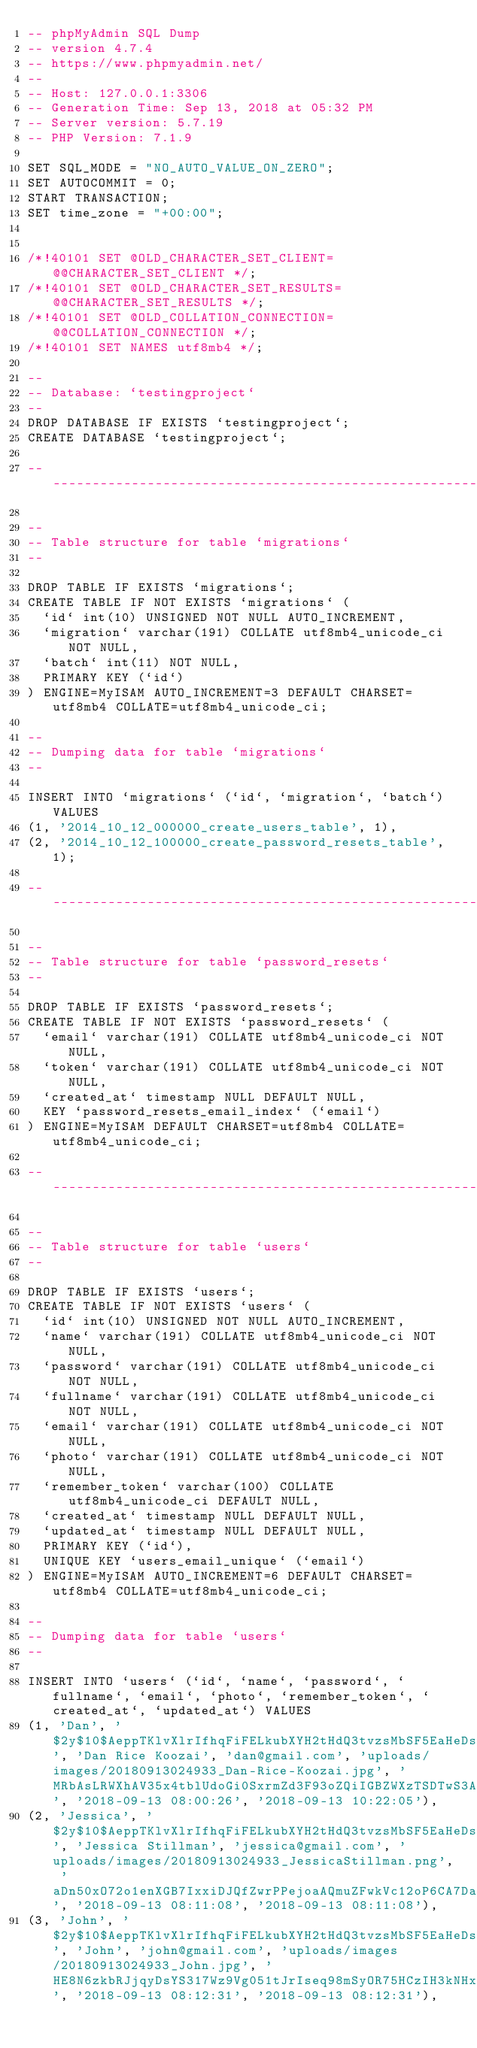<code> <loc_0><loc_0><loc_500><loc_500><_SQL_>-- phpMyAdmin SQL Dump
-- version 4.7.4
-- https://www.phpmyadmin.net/
--
-- Host: 127.0.0.1:3306
-- Generation Time: Sep 13, 2018 at 05:32 PM
-- Server version: 5.7.19
-- PHP Version: 7.1.9

SET SQL_MODE = "NO_AUTO_VALUE_ON_ZERO";
SET AUTOCOMMIT = 0;
START TRANSACTION;
SET time_zone = "+00:00";


/*!40101 SET @OLD_CHARACTER_SET_CLIENT=@@CHARACTER_SET_CLIENT */;
/*!40101 SET @OLD_CHARACTER_SET_RESULTS=@@CHARACTER_SET_RESULTS */;
/*!40101 SET @OLD_COLLATION_CONNECTION=@@COLLATION_CONNECTION */;
/*!40101 SET NAMES utf8mb4 */;

--
-- Database: `testingproject`
--
DROP DATABASE IF EXISTS `testingproject`;
CREATE DATABASE `testingproject`;

-- --------------------------------------------------------

--
-- Table structure for table `migrations`
--

DROP TABLE IF EXISTS `migrations`;
CREATE TABLE IF NOT EXISTS `migrations` (
  `id` int(10) UNSIGNED NOT NULL AUTO_INCREMENT,
  `migration` varchar(191) COLLATE utf8mb4_unicode_ci NOT NULL,
  `batch` int(11) NOT NULL,
  PRIMARY KEY (`id`)
) ENGINE=MyISAM AUTO_INCREMENT=3 DEFAULT CHARSET=utf8mb4 COLLATE=utf8mb4_unicode_ci;

--
-- Dumping data for table `migrations`
--

INSERT INTO `migrations` (`id`, `migration`, `batch`) VALUES
(1, '2014_10_12_000000_create_users_table', 1),
(2, '2014_10_12_100000_create_password_resets_table', 1);

-- --------------------------------------------------------

--
-- Table structure for table `password_resets`
--

DROP TABLE IF EXISTS `password_resets`;
CREATE TABLE IF NOT EXISTS `password_resets` (
  `email` varchar(191) COLLATE utf8mb4_unicode_ci NOT NULL,
  `token` varchar(191) COLLATE utf8mb4_unicode_ci NOT NULL,
  `created_at` timestamp NULL DEFAULT NULL,
  KEY `password_resets_email_index` (`email`)
) ENGINE=MyISAM DEFAULT CHARSET=utf8mb4 COLLATE=utf8mb4_unicode_ci;

-- --------------------------------------------------------

--
-- Table structure for table `users`
--

DROP TABLE IF EXISTS `users`;
CREATE TABLE IF NOT EXISTS `users` (
  `id` int(10) UNSIGNED NOT NULL AUTO_INCREMENT,
  `name` varchar(191) COLLATE utf8mb4_unicode_ci NOT NULL,
  `password` varchar(191) COLLATE utf8mb4_unicode_ci NOT NULL,
  `fullname` varchar(191) COLLATE utf8mb4_unicode_ci NOT NULL,
  `email` varchar(191) COLLATE utf8mb4_unicode_ci NOT NULL,
  `photo` varchar(191) COLLATE utf8mb4_unicode_ci NOT NULL,
  `remember_token` varchar(100) COLLATE utf8mb4_unicode_ci DEFAULT NULL,
  `created_at` timestamp NULL DEFAULT NULL,
  `updated_at` timestamp NULL DEFAULT NULL,
  PRIMARY KEY (`id`),
  UNIQUE KEY `users_email_unique` (`email`)
) ENGINE=MyISAM AUTO_INCREMENT=6 DEFAULT CHARSET=utf8mb4 COLLATE=utf8mb4_unicode_ci;

--
-- Dumping data for table `users`
--

INSERT INTO `users` (`id`, `name`, `password`, `fullname`, `email`, `photo`, `remember_token`, `created_at`, `updated_at`) VALUES
(1, 'Dan', '$2y$10$AeppTKlvXlrIfhqFiFELkubXYH2tHdQ3tvzsMbSF5EaHeDsPaUZ96', 'Dan Rice Koozai', 'dan@gmail.com', 'uploads/images/20180913024933_Dan-Rice-Koozai.jpg', 'MRbAsLRWXhAV35x4tblUdoGi0SxrmZd3F93oZQiIGBZWXzTSDTwS3AwFbKLM', '2018-09-13 08:00:26', '2018-09-13 10:22:05'),
(2, 'Jessica', '$2y$10$AeppTKlvXlrIfhqFiFELkubXYH2tHdQ3tvzsMbSF5EaHeDsPaUZ96', 'Jessica Stillman', 'jessica@gmail.com', 'uploads/images/20180913024933_JessicaStillman.png', 'aDn50xO72o1enXGB7IxxiDJQfZwrPPejoaAQmuZFwkVc12oP6CA7DaZlHSkj', '2018-09-13 08:11:08', '2018-09-13 08:11:08'),
(3, 'John', '$2y$10$AeppTKlvXlrIfhqFiFELkubXYH2tHdQ3tvzsMbSF5EaHeDsPaUZ96', 'John', 'john@gmail.com', 'uploads/images/20180913024933_John.jpg', 'HE8N6zkbRJjqyDsYS317Wz9Vg051tJrIseq98mSyOR75HCzIH3kNHxXsIEk4', '2018-09-13 08:12:31', '2018-09-13 08:12:31'),</code> 